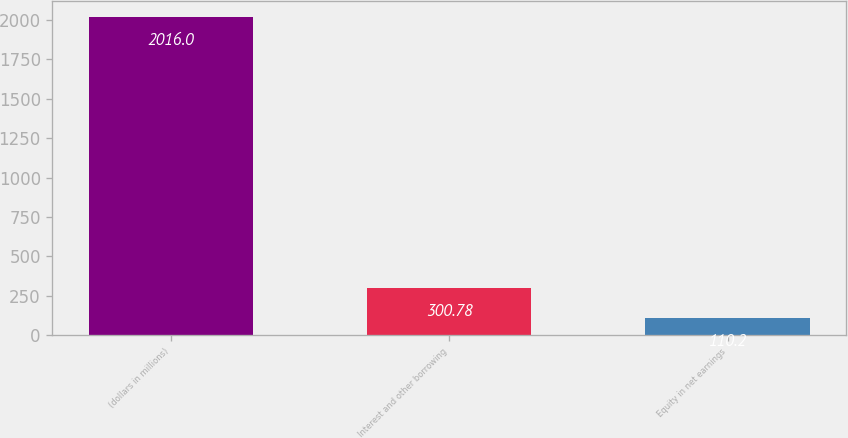<chart> <loc_0><loc_0><loc_500><loc_500><bar_chart><fcel>(dollars in millions)<fcel>Interest and other borrowing<fcel>Equity in net earnings<nl><fcel>2016<fcel>300.78<fcel>110.2<nl></chart> 